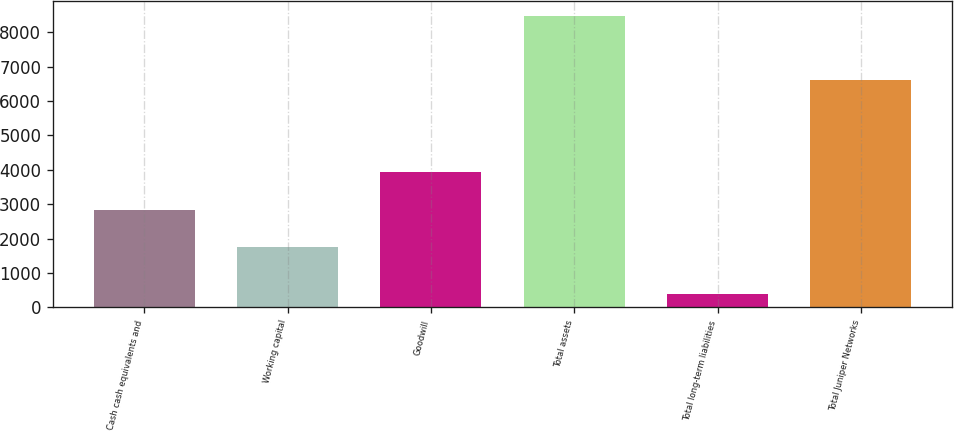Convert chart to OTSL. <chart><loc_0><loc_0><loc_500><loc_500><bar_chart><fcel>Cash cash equivalents and<fcel>Working capital<fcel>Goodwill<fcel>Total assets<fcel>Total long-term liabilities<fcel>Total Juniper Networks<nl><fcel>2821.6<fcel>1742.4<fcel>3927.8<fcel>8467.9<fcel>387.1<fcel>6608.2<nl></chart> 